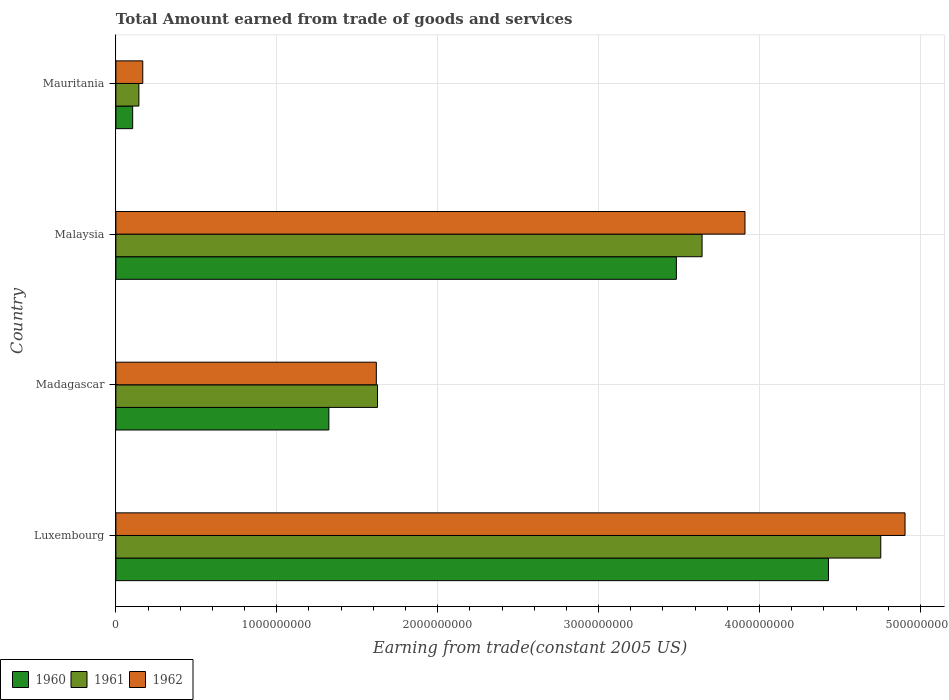How many groups of bars are there?
Offer a very short reply. 4. Are the number of bars on each tick of the Y-axis equal?
Offer a very short reply. Yes. How many bars are there on the 2nd tick from the top?
Provide a short and direct response. 3. How many bars are there on the 1st tick from the bottom?
Offer a terse response. 3. What is the label of the 4th group of bars from the top?
Provide a short and direct response. Luxembourg. In how many cases, is the number of bars for a given country not equal to the number of legend labels?
Your answer should be very brief. 0. What is the total amount earned by trading goods and services in 1960 in Malaysia?
Give a very brief answer. 3.48e+09. Across all countries, what is the maximum total amount earned by trading goods and services in 1961?
Your response must be concise. 4.75e+09. Across all countries, what is the minimum total amount earned by trading goods and services in 1961?
Your answer should be very brief. 1.43e+08. In which country was the total amount earned by trading goods and services in 1961 maximum?
Offer a very short reply. Luxembourg. In which country was the total amount earned by trading goods and services in 1960 minimum?
Keep it short and to the point. Mauritania. What is the total total amount earned by trading goods and services in 1960 in the graph?
Offer a terse response. 9.34e+09. What is the difference between the total amount earned by trading goods and services in 1962 in Malaysia and that in Mauritania?
Offer a terse response. 3.74e+09. What is the difference between the total amount earned by trading goods and services in 1962 in Luxembourg and the total amount earned by trading goods and services in 1960 in Mauritania?
Ensure brevity in your answer.  4.80e+09. What is the average total amount earned by trading goods and services in 1962 per country?
Provide a succinct answer. 2.65e+09. What is the difference between the total amount earned by trading goods and services in 1960 and total amount earned by trading goods and services in 1961 in Luxembourg?
Offer a terse response. -3.25e+08. What is the ratio of the total amount earned by trading goods and services in 1961 in Luxembourg to that in Mauritania?
Make the answer very short. 33.28. Is the difference between the total amount earned by trading goods and services in 1960 in Madagascar and Malaysia greater than the difference between the total amount earned by trading goods and services in 1961 in Madagascar and Malaysia?
Offer a terse response. No. What is the difference between the highest and the second highest total amount earned by trading goods and services in 1960?
Ensure brevity in your answer.  9.45e+08. What is the difference between the highest and the lowest total amount earned by trading goods and services in 1962?
Ensure brevity in your answer.  4.74e+09. In how many countries, is the total amount earned by trading goods and services in 1962 greater than the average total amount earned by trading goods and services in 1962 taken over all countries?
Provide a succinct answer. 2. Is the sum of the total amount earned by trading goods and services in 1961 in Luxembourg and Mauritania greater than the maximum total amount earned by trading goods and services in 1962 across all countries?
Provide a short and direct response. No. What does the 3rd bar from the top in Luxembourg represents?
Provide a succinct answer. 1960. What does the 1st bar from the bottom in Luxembourg represents?
Provide a succinct answer. 1960. Is it the case that in every country, the sum of the total amount earned by trading goods and services in 1961 and total amount earned by trading goods and services in 1960 is greater than the total amount earned by trading goods and services in 1962?
Provide a short and direct response. Yes. How many countries are there in the graph?
Provide a short and direct response. 4. What is the difference between two consecutive major ticks on the X-axis?
Offer a terse response. 1.00e+09. Does the graph contain grids?
Ensure brevity in your answer.  Yes. How many legend labels are there?
Make the answer very short. 3. What is the title of the graph?
Provide a short and direct response. Total Amount earned from trade of goods and services. What is the label or title of the X-axis?
Offer a very short reply. Earning from trade(constant 2005 US). What is the Earning from trade(constant 2005 US) in 1960 in Luxembourg?
Provide a short and direct response. 4.43e+09. What is the Earning from trade(constant 2005 US) in 1961 in Luxembourg?
Your response must be concise. 4.75e+09. What is the Earning from trade(constant 2005 US) of 1962 in Luxembourg?
Make the answer very short. 4.90e+09. What is the Earning from trade(constant 2005 US) of 1960 in Madagascar?
Provide a short and direct response. 1.32e+09. What is the Earning from trade(constant 2005 US) in 1961 in Madagascar?
Offer a very short reply. 1.63e+09. What is the Earning from trade(constant 2005 US) of 1962 in Madagascar?
Provide a succinct answer. 1.62e+09. What is the Earning from trade(constant 2005 US) in 1960 in Malaysia?
Your answer should be compact. 3.48e+09. What is the Earning from trade(constant 2005 US) of 1961 in Malaysia?
Ensure brevity in your answer.  3.64e+09. What is the Earning from trade(constant 2005 US) of 1962 in Malaysia?
Your answer should be very brief. 3.91e+09. What is the Earning from trade(constant 2005 US) of 1960 in Mauritania?
Your response must be concise. 1.04e+08. What is the Earning from trade(constant 2005 US) of 1961 in Mauritania?
Ensure brevity in your answer.  1.43e+08. What is the Earning from trade(constant 2005 US) of 1962 in Mauritania?
Ensure brevity in your answer.  1.67e+08. Across all countries, what is the maximum Earning from trade(constant 2005 US) in 1960?
Provide a succinct answer. 4.43e+09. Across all countries, what is the maximum Earning from trade(constant 2005 US) of 1961?
Keep it short and to the point. 4.75e+09. Across all countries, what is the maximum Earning from trade(constant 2005 US) in 1962?
Provide a short and direct response. 4.90e+09. Across all countries, what is the minimum Earning from trade(constant 2005 US) of 1960?
Make the answer very short. 1.04e+08. Across all countries, what is the minimum Earning from trade(constant 2005 US) of 1961?
Offer a very short reply. 1.43e+08. Across all countries, what is the minimum Earning from trade(constant 2005 US) in 1962?
Offer a terse response. 1.67e+08. What is the total Earning from trade(constant 2005 US) of 1960 in the graph?
Offer a terse response. 9.34e+09. What is the total Earning from trade(constant 2005 US) in 1961 in the graph?
Ensure brevity in your answer.  1.02e+1. What is the total Earning from trade(constant 2005 US) in 1962 in the graph?
Give a very brief answer. 1.06e+1. What is the difference between the Earning from trade(constant 2005 US) of 1960 in Luxembourg and that in Madagascar?
Your answer should be compact. 3.11e+09. What is the difference between the Earning from trade(constant 2005 US) in 1961 in Luxembourg and that in Madagascar?
Provide a short and direct response. 3.13e+09. What is the difference between the Earning from trade(constant 2005 US) in 1962 in Luxembourg and that in Madagascar?
Ensure brevity in your answer.  3.29e+09. What is the difference between the Earning from trade(constant 2005 US) of 1960 in Luxembourg and that in Malaysia?
Keep it short and to the point. 9.45e+08. What is the difference between the Earning from trade(constant 2005 US) of 1961 in Luxembourg and that in Malaysia?
Offer a very short reply. 1.11e+09. What is the difference between the Earning from trade(constant 2005 US) in 1962 in Luxembourg and that in Malaysia?
Offer a very short reply. 9.95e+08. What is the difference between the Earning from trade(constant 2005 US) of 1960 in Luxembourg and that in Mauritania?
Your answer should be compact. 4.32e+09. What is the difference between the Earning from trade(constant 2005 US) of 1961 in Luxembourg and that in Mauritania?
Provide a succinct answer. 4.61e+09. What is the difference between the Earning from trade(constant 2005 US) in 1962 in Luxembourg and that in Mauritania?
Your answer should be very brief. 4.74e+09. What is the difference between the Earning from trade(constant 2005 US) in 1960 in Madagascar and that in Malaysia?
Provide a short and direct response. -2.16e+09. What is the difference between the Earning from trade(constant 2005 US) in 1961 in Madagascar and that in Malaysia?
Keep it short and to the point. -2.02e+09. What is the difference between the Earning from trade(constant 2005 US) of 1962 in Madagascar and that in Malaysia?
Provide a succinct answer. -2.29e+09. What is the difference between the Earning from trade(constant 2005 US) of 1960 in Madagascar and that in Mauritania?
Make the answer very short. 1.22e+09. What is the difference between the Earning from trade(constant 2005 US) in 1961 in Madagascar and that in Mauritania?
Your answer should be compact. 1.48e+09. What is the difference between the Earning from trade(constant 2005 US) in 1962 in Madagascar and that in Mauritania?
Provide a succinct answer. 1.45e+09. What is the difference between the Earning from trade(constant 2005 US) of 1960 in Malaysia and that in Mauritania?
Your response must be concise. 3.38e+09. What is the difference between the Earning from trade(constant 2005 US) in 1961 in Malaysia and that in Mauritania?
Keep it short and to the point. 3.50e+09. What is the difference between the Earning from trade(constant 2005 US) in 1962 in Malaysia and that in Mauritania?
Give a very brief answer. 3.74e+09. What is the difference between the Earning from trade(constant 2005 US) in 1960 in Luxembourg and the Earning from trade(constant 2005 US) in 1961 in Madagascar?
Keep it short and to the point. 2.80e+09. What is the difference between the Earning from trade(constant 2005 US) in 1960 in Luxembourg and the Earning from trade(constant 2005 US) in 1962 in Madagascar?
Offer a terse response. 2.81e+09. What is the difference between the Earning from trade(constant 2005 US) in 1961 in Luxembourg and the Earning from trade(constant 2005 US) in 1962 in Madagascar?
Your answer should be compact. 3.14e+09. What is the difference between the Earning from trade(constant 2005 US) of 1960 in Luxembourg and the Earning from trade(constant 2005 US) of 1961 in Malaysia?
Make the answer very short. 7.86e+08. What is the difference between the Earning from trade(constant 2005 US) of 1960 in Luxembourg and the Earning from trade(constant 2005 US) of 1962 in Malaysia?
Your answer should be very brief. 5.19e+08. What is the difference between the Earning from trade(constant 2005 US) of 1961 in Luxembourg and the Earning from trade(constant 2005 US) of 1962 in Malaysia?
Your answer should be compact. 8.44e+08. What is the difference between the Earning from trade(constant 2005 US) of 1960 in Luxembourg and the Earning from trade(constant 2005 US) of 1961 in Mauritania?
Your response must be concise. 4.29e+09. What is the difference between the Earning from trade(constant 2005 US) in 1960 in Luxembourg and the Earning from trade(constant 2005 US) in 1962 in Mauritania?
Your answer should be compact. 4.26e+09. What is the difference between the Earning from trade(constant 2005 US) of 1961 in Luxembourg and the Earning from trade(constant 2005 US) of 1962 in Mauritania?
Your response must be concise. 4.59e+09. What is the difference between the Earning from trade(constant 2005 US) in 1960 in Madagascar and the Earning from trade(constant 2005 US) in 1961 in Malaysia?
Make the answer very short. -2.32e+09. What is the difference between the Earning from trade(constant 2005 US) of 1960 in Madagascar and the Earning from trade(constant 2005 US) of 1962 in Malaysia?
Provide a succinct answer. -2.59e+09. What is the difference between the Earning from trade(constant 2005 US) in 1961 in Madagascar and the Earning from trade(constant 2005 US) in 1962 in Malaysia?
Your answer should be very brief. -2.28e+09. What is the difference between the Earning from trade(constant 2005 US) of 1960 in Madagascar and the Earning from trade(constant 2005 US) of 1961 in Mauritania?
Offer a terse response. 1.18e+09. What is the difference between the Earning from trade(constant 2005 US) in 1960 in Madagascar and the Earning from trade(constant 2005 US) in 1962 in Mauritania?
Offer a terse response. 1.16e+09. What is the difference between the Earning from trade(constant 2005 US) in 1961 in Madagascar and the Earning from trade(constant 2005 US) in 1962 in Mauritania?
Provide a succinct answer. 1.46e+09. What is the difference between the Earning from trade(constant 2005 US) of 1960 in Malaysia and the Earning from trade(constant 2005 US) of 1961 in Mauritania?
Your answer should be compact. 3.34e+09. What is the difference between the Earning from trade(constant 2005 US) in 1960 in Malaysia and the Earning from trade(constant 2005 US) in 1962 in Mauritania?
Make the answer very short. 3.32e+09. What is the difference between the Earning from trade(constant 2005 US) of 1961 in Malaysia and the Earning from trade(constant 2005 US) of 1962 in Mauritania?
Your response must be concise. 3.48e+09. What is the average Earning from trade(constant 2005 US) of 1960 per country?
Ensure brevity in your answer.  2.34e+09. What is the average Earning from trade(constant 2005 US) of 1961 per country?
Offer a terse response. 2.54e+09. What is the average Earning from trade(constant 2005 US) in 1962 per country?
Offer a very short reply. 2.65e+09. What is the difference between the Earning from trade(constant 2005 US) in 1960 and Earning from trade(constant 2005 US) in 1961 in Luxembourg?
Provide a short and direct response. -3.25e+08. What is the difference between the Earning from trade(constant 2005 US) of 1960 and Earning from trade(constant 2005 US) of 1962 in Luxembourg?
Keep it short and to the point. -4.76e+08. What is the difference between the Earning from trade(constant 2005 US) in 1961 and Earning from trade(constant 2005 US) in 1962 in Luxembourg?
Your answer should be very brief. -1.51e+08. What is the difference between the Earning from trade(constant 2005 US) in 1960 and Earning from trade(constant 2005 US) in 1961 in Madagascar?
Make the answer very short. -3.02e+08. What is the difference between the Earning from trade(constant 2005 US) of 1960 and Earning from trade(constant 2005 US) of 1962 in Madagascar?
Your answer should be compact. -2.95e+08. What is the difference between the Earning from trade(constant 2005 US) in 1961 and Earning from trade(constant 2005 US) in 1962 in Madagascar?
Offer a terse response. 7.38e+06. What is the difference between the Earning from trade(constant 2005 US) in 1960 and Earning from trade(constant 2005 US) in 1961 in Malaysia?
Keep it short and to the point. -1.60e+08. What is the difference between the Earning from trade(constant 2005 US) in 1960 and Earning from trade(constant 2005 US) in 1962 in Malaysia?
Offer a very short reply. -4.26e+08. What is the difference between the Earning from trade(constant 2005 US) of 1961 and Earning from trade(constant 2005 US) of 1962 in Malaysia?
Ensure brevity in your answer.  -2.67e+08. What is the difference between the Earning from trade(constant 2005 US) of 1960 and Earning from trade(constant 2005 US) of 1961 in Mauritania?
Your answer should be compact. -3.85e+07. What is the difference between the Earning from trade(constant 2005 US) in 1960 and Earning from trade(constant 2005 US) in 1962 in Mauritania?
Keep it short and to the point. -6.27e+07. What is the difference between the Earning from trade(constant 2005 US) of 1961 and Earning from trade(constant 2005 US) of 1962 in Mauritania?
Give a very brief answer. -2.42e+07. What is the ratio of the Earning from trade(constant 2005 US) of 1960 in Luxembourg to that in Madagascar?
Offer a terse response. 3.35. What is the ratio of the Earning from trade(constant 2005 US) in 1961 in Luxembourg to that in Madagascar?
Your answer should be compact. 2.92. What is the ratio of the Earning from trade(constant 2005 US) of 1962 in Luxembourg to that in Madagascar?
Provide a short and direct response. 3.03. What is the ratio of the Earning from trade(constant 2005 US) in 1960 in Luxembourg to that in Malaysia?
Keep it short and to the point. 1.27. What is the ratio of the Earning from trade(constant 2005 US) of 1961 in Luxembourg to that in Malaysia?
Your answer should be very brief. 1.3. What is the ratio of the Earning from trade(constant 2005 US) in 1962 in Luxembourg to that in Malaysia?
Your answer should be very brief. 1.25. What is the ratio of the Earning from trade(constant 2005 US) in 1960 in Luxembourg to that in Mauritania?
Your response must be concise. 42.45. What is the ratio of the Earning from trade(constant 2005 US) in 1961 in Luxembourg to that in Mauritania?
Your answer should be very brief. 33.28. What is the ratio of the Earning from trade(constant 2005 US) in 1962 in Luxembourg to that in Mauritania?
Offer a terse response. 29.37. What is the ratio of the Earning from trade(constant 2005 US) in 1960 in Madagascar to that in Malaysia?
Give a very brief answer. 0.38. What is the ratio of the Earning from trade(constant 2005 US) in 1961 in Madagascar to that in Malaysia?
Your answer should be very brief. 0.45. What is the ratio of the Earning from trade(constant 2005 US) of 1962 in Madagascar to that in Malaysia?
Keep it short and to the point. 0.41. What is the ratio of the Earning from trade(constant 2005 US) in 1960 in Madagascar to that in Mauritania?
Your answer should be compact. 12.69. What is the ratio of the Earning from trade(constant 2005 US) of 1961 in Madagascar to that in Mauritania?
Provide a short and direct response. 11.38. What is the ratio of the Earning from trade(constant 2005 US) of 1962 in Madagascar to that in Mauritania?
Give a very brief answer. 9.69. What is the ratio of the Earning from trade(constant 2005 US) in 1960 in Malaysia to that in Mauritania?
Provide a succinct answer. 33.39. What is the ratio of the Earning from trade(constant 2005 US) in 1961 in Malaysia to that in Mauritania?
Give a very brief answer. 25.51. What is the ratio of the Earning from trade(constant 2005 US) of 1962 in Malaysia to that in Mauritania?
Provide a short and direct response. 23.41. What is the difference between the highest and the second highest Earning from trade(constant 2005 US) of 1960?
Provide a short and direct response. 9.45e+08. What is the difference between the highest and the second highest Earning from trade(constant 2005 US) of 1961?
Ensure brevity in your answer.  1.11e+09. What is the difference between the highest and the second highest Earning from trade(constant 2005 US) in 1962?
Your answer should be very brief. 9.95e+08. What is the difference between the highest and the lowest Earning from trade(constant 2005 US) in 1960?
Provide a succinct answer. 4.32e+09. What is the difference between the highest and the lowest Earning from trade(constant 2005 US) in 1961?
Give a very brief answer. 4.61e+09. What is the difference between the highest and the lowest Earning from trade(constant 2005 US) of 1962?
Make the answer very short. 4.74e+09. 